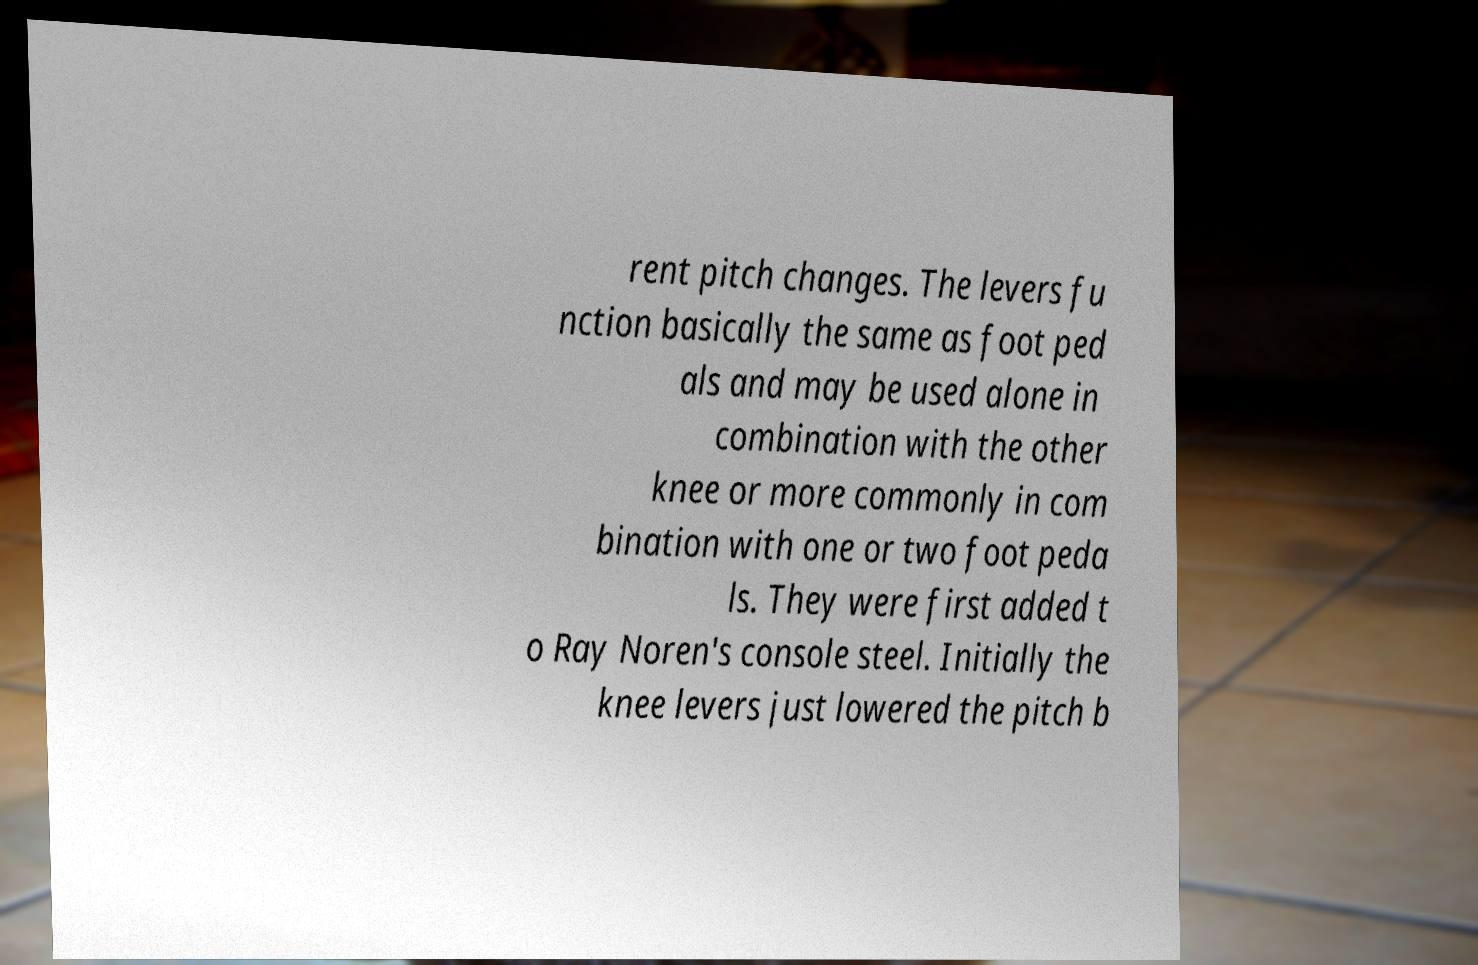What messages or text are displayed in this image? I need them in a readable, typed format. rent pitch changes. The levers fu nction basically the same as foot ped als and may be used alone in combination with the other knee or more commonly in com bination with one or two foot peda ls. They were first added t o Ray Noren's console steel. Initially the knee levers just lowered the pitch b 